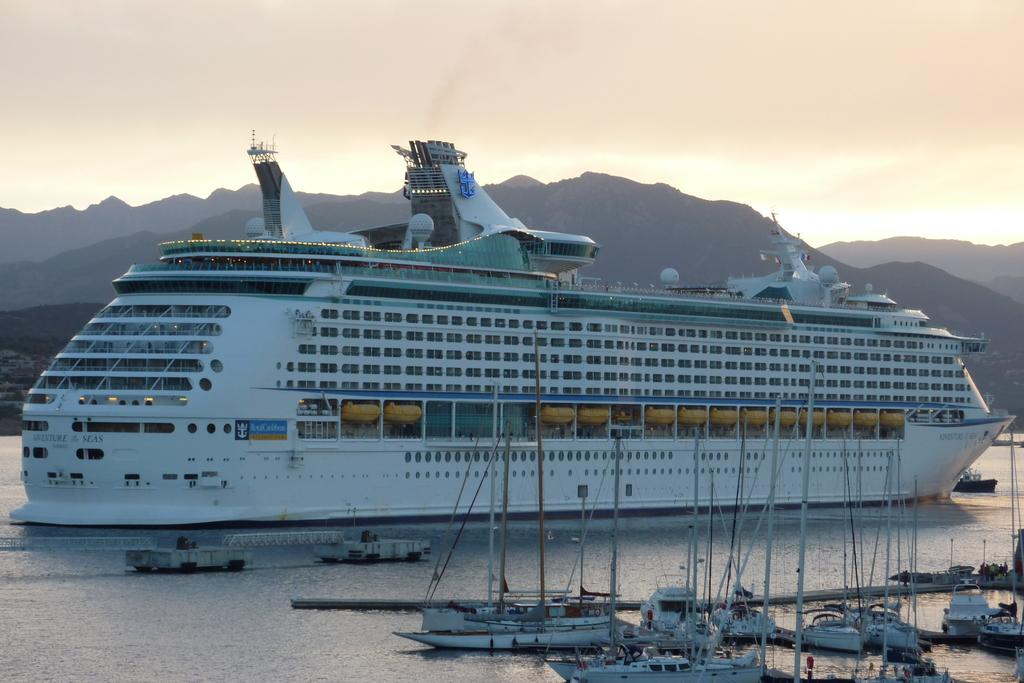What can be seen in the foreground of the picture? There are boats in the foreground of the picture. What is the main subject in the center of the picture? There is a ship in the center of the picture. What type of landscape is visible in the image? There is a water body and hills visible in the image. What type of powder is being used by the crook in the image? There is no crook or powder present in the image. What achievement is the achiever celebrating in the image? There is no achiever or celebration present in the image. 